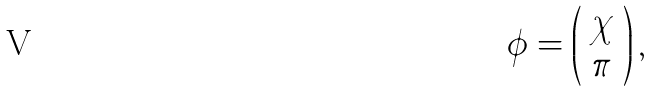Convert formula to latex. <formula><loc_0><loc_0><loc_500><loc_500>\phi = \left ( \begin{array} { c } \chi \\ \pi \end{array} \right ) ,</formula> 